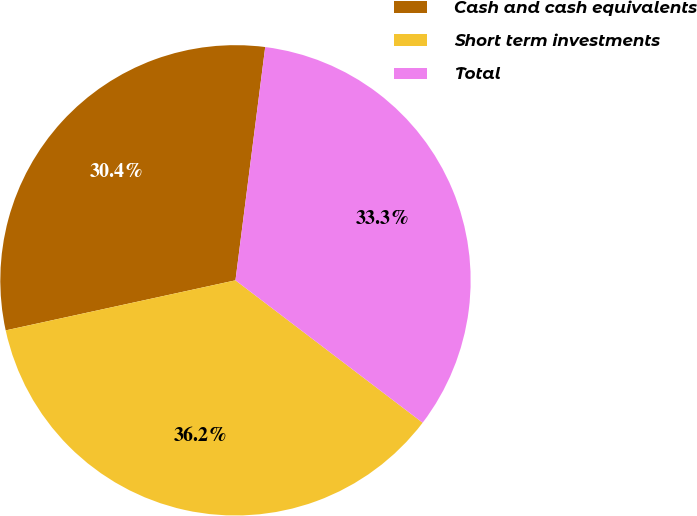<chart> <loc_0><loc_0><loc_500><loc_500><pie_chart><fcel>Cash and cash equivalents<fcel>Short term investments<fcel>Total<nl><fcel>30.43%<fcel>36.23%<fcel>33.33%<nl></chart> 